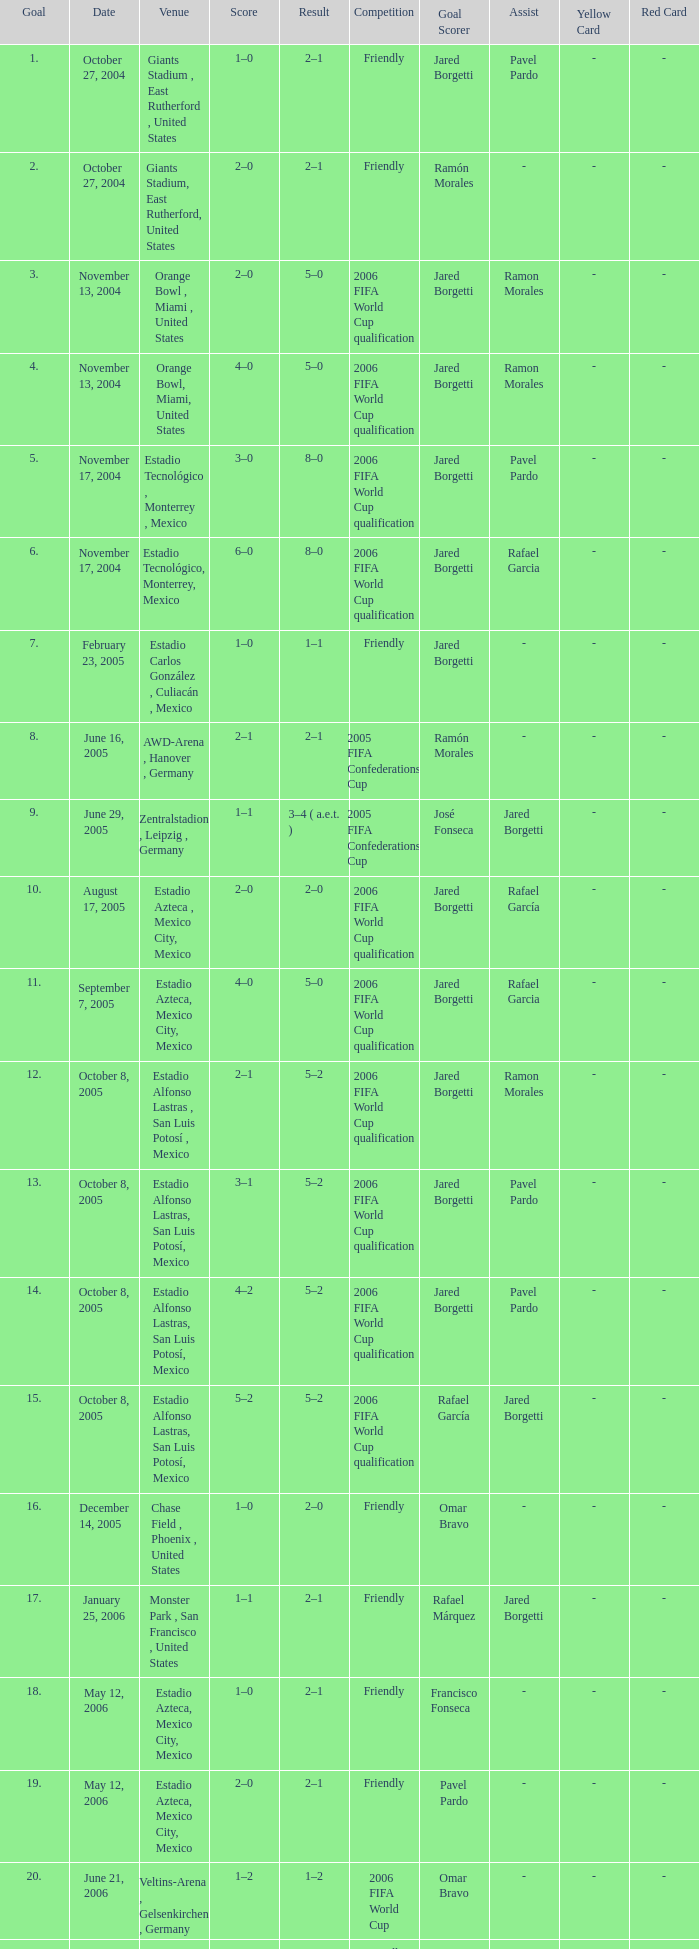Which Competition has a Venue of estadio alfonso lastras, san luis potosí, mexico, and a Goal larger than 15? Friendly. 